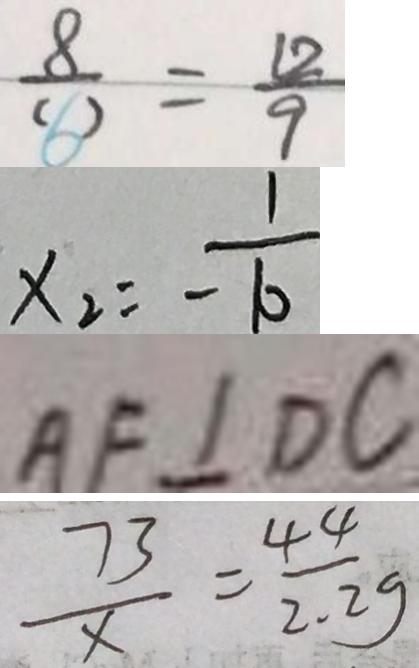<formula> <loc_0><loc_0><loc_500><loc_500>\frac { 8 } { ( 6 ) } = \frac { 1 2 } { 9 } 
 x _ { 2 } = \frac { 1 } { - 1 0 } 
 A F \bot D C 
 \frac { 7 3 } { x } = \frac { 4 4 } { 2 . 2 g }</formula> 